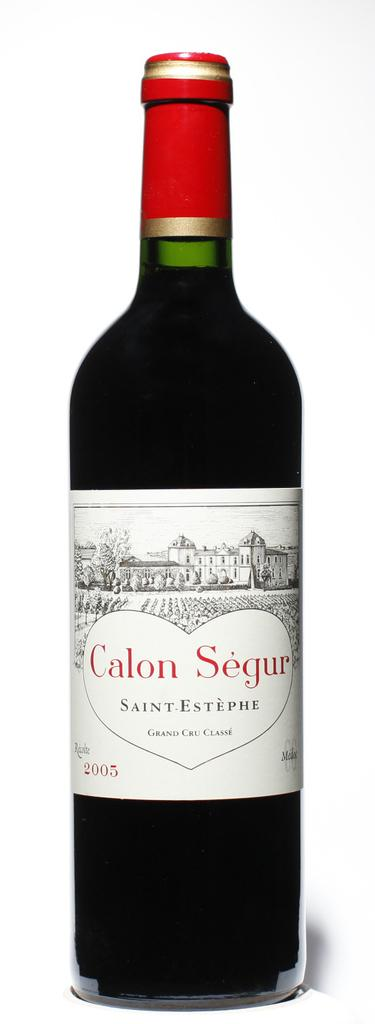<image>
Describe the image concisely. The Saint-Estephe Calon Segur Grand Cru Classe is dated 2005. 